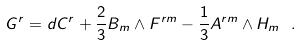<formula> <loc_0><loc_0><loc_500><loc_500>G ^ { r } = d C ^ { r } + \frac { 2 } { 3 } B _ { m } \wedge F ^ { r m } - \frac { 1 } { 3 } A ^ { r m } \wedge H _ { m } \ .</formula> 